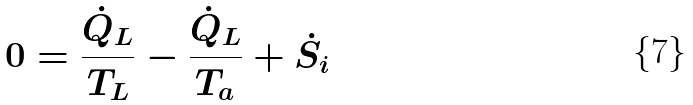Convert formula to latex. <formula><loc_0><loc_0><loc_500><loc_500>0 = \frac { \dot { Q } _ { L } } { T _ { L } } - \frac { \dot { Q } _ { L } } { T _ { a } } + \dot { S } _ { i }</formula> 